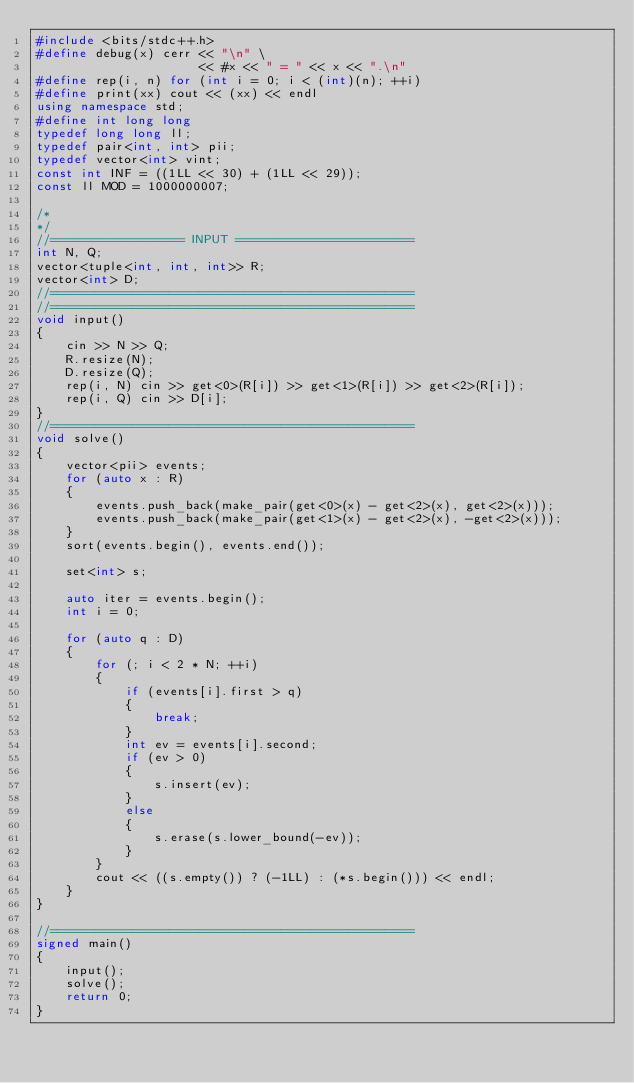<code> <loc_0><loc_0><loc_500><loc_500><_C++_>#include <bits/stdc++.h>
#define debug(x) cerr << "\n" \
                      << #x << " = " << x << ".\n"
#define rep(i, n) for (int i = 0; i < (int)(n); ++i)
#define print(xx) cout << (xx) << endl
using namespace std;
#define int long long
typedef long long ll;
typedef pair<int, int> pii;
typedef vector<int> vint;
const int INF = ((1LL << 30) + (1LL << 29));
const ll MOD = 1000000007;

/* 
*/
//================== INPUT ========================
int N, Q;
vector<tuple<int, int, int>> R;
vector<int> D;
//=================================================
//=================================================
void input()
{
    cin >> N >> Q;
    R.resize(N);
    D.resize(Q);
    rep(i, N) cin >> get<0>(R[i]) >> get<1>(R[i]) >> get<2>(R[i]);
    rep(i, Q) cin >> D[i];
}
//=================================================
void solve()
{
    vector<pii> events;
    for (auto x : R)
    {
        events.push_back(make_pair(get<0>(x) - get<2>(x), get<2>(x)));
        events.push_back(make_pair(get<1>(x) - get<2>(x), -get<2>(x)));
    }
    sort(events.begin(), events.end());

    set<int> s;

    auto iter = events.begin();
    int i = 0;

    for (auto q : D)
    {
        for (; i < 2 * N; ++i)
        {
            if (events[i].first > q)
            {
                break;
            }
            int ev = events[i].second;
            if (ev > 0)
            {
                s.insert(ev);
            }
            else
            {
                s.erase(s.lower_bound(-ev));
            }
        }
        cout << ((s.empty()) ? (-1LL) : (*s.begin())) << endl;
    }
}

//=================================================
signed main()
{
    input();
    solve();
    return 0;
}</code> 